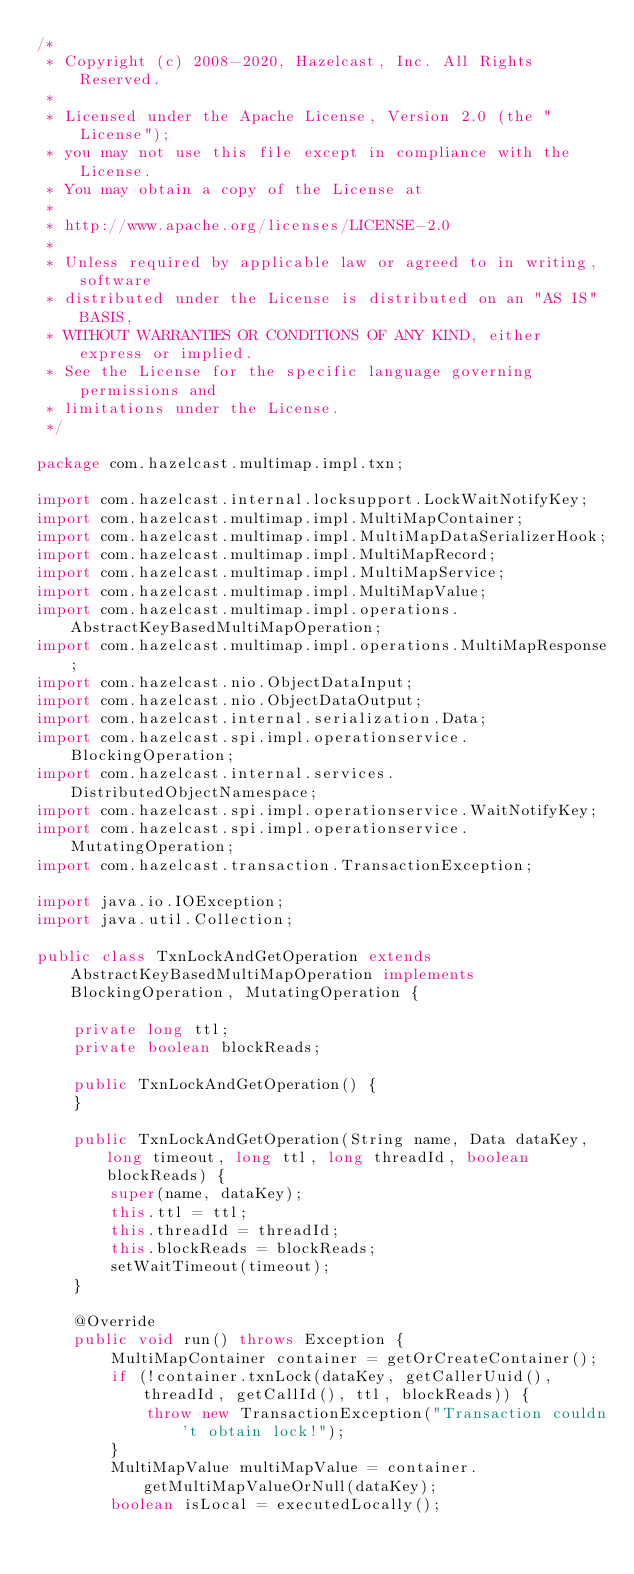<code> <loc_0><loc_0><loc_500><loc_500><_Java_>/*
 * Copyright (c) 2008-2020, Hazelcast, Inc. All Rights Reserved.
 *
 * Licensed under the Apache License, Version 2.0 (the "License");
 * you may not use this file except in compliance with the License.
 * You may obtain a copy of the License at
 *
 * http://www.apache.org/licenses/LICENSE-2.0
 *
 * Unless required by applicable law or agreed to in writing, software
 * distributed under the License is distributed on an "AS IS" BASIS,
 * WITHOUT WARRANTIES OR CONDITIONS OF ANY KIND, either express or implied.
 * See the License for the specific language governing permissions and
 * limitations under the License.
 */

package com.hazelcast.multimap.impl.txn;

import com.hazelcast.internal.locksupport.LockWaitNotifyKey;
import com.hazelcast.multimap.impl.MultiMapContainer;
import com.hazelcast.multimap.impl.MultiMapDataSerializerHook;
import com.hazelcast.multimap.impl.MultiMapRecord;
import com.hazelcast.multimap.impl.MultiMapService;
import com.hazelcast.multimap.impl.MultiMapValue;
import com.hazelcast.multimap.impl.operations.AbstractKeyBasedMultiMapOperation;
import com.hazelcast.multimap.impl.operations.MultiMapResponse;
import com.hazelcast.nio.ObjectDataInput;
import com.hazelcast.nio.ObjectDataOutput;
import com.hazelcast.internal.serialization.Data;
import com.hazelcast.spi.impl.operationservice.BlockingOperation;
import com.hazelcast.internal.services.DistributedObjectNamespace;
import com.hazelcast.spi.impl.operationservice.WaitNotifyKey;
import com.hazelcast.spi.impl.operationservice.MutatingOperation;
import com.hazelcast.transaction.TransactionException;

import java.io.IOException;
import java.util.Collection;

public class TxnLockAndGetOperation extends AbstractKeyBasedMultiMapOperation implements BlockingOperation, MutatingOperation {

    private long ttl;
    private boolean blockReads;

    public TxnLockAndGetOperation() {
    }

    public TxnLockAndGetOperation(String name, Data dataKey, long timeout, long ttl, long threadId, boolean blockReads) {
        super(name, dataKey);
        this.ttl = ttl;
        this.threadId = threadId;
        this.blockReads = blockReads;
        setWaitTimeout(timeout);
    }

    @Override
    public void run() throws Exception {
        MultiMapContainer container = getOrCreateContainer();
        if (!container.txnLock(dataKey, getCallerUuid(), threadId, getCallId(), ttl, blockReads)) {
            throw new TransactionException("Transaction couldn't obtain lock!");
        }
        MultiMapValue multiMapValue = container.getMultiMapValueOrNull(dataKey);
        boolean isLocal = executedLocally();</code> 